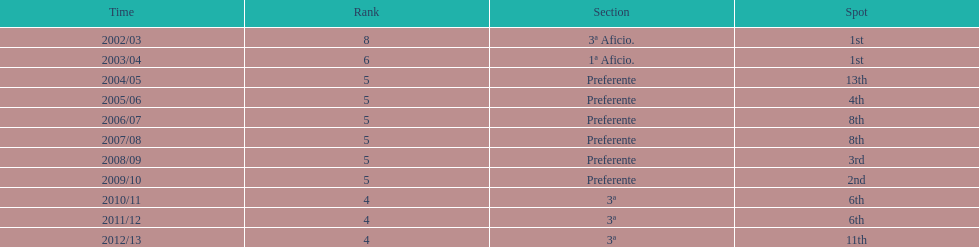In what year did the team achieve the same place as 2010/11? 2011/12. 